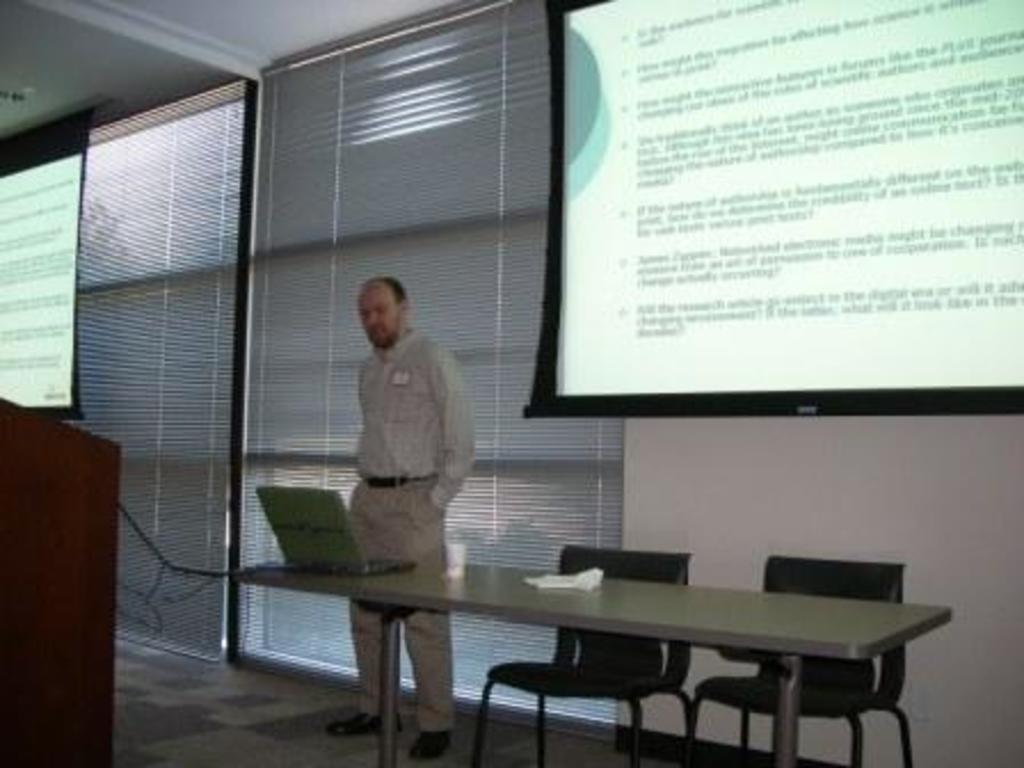What is the main subject in the image? There is a man standing in the image. What objects are present in the image that might be used for seating? There are chairs in the image. What object is present in the image that might be used for presentations? There is a podium in the image. What objects are present in the image that might be used for displaying information? There are projector screens in the image. What object is present in the image that might be used for holding items? There is a table in the image. What object is present on the table in the image? There is a laptop on the table. What type of punishment is being administered to the man in the image? There is no indication of punishment in the image; the man is simply standing. What type of substance is being used to clean the table in the image? There is no substance visible in the image being used to clean the table. 